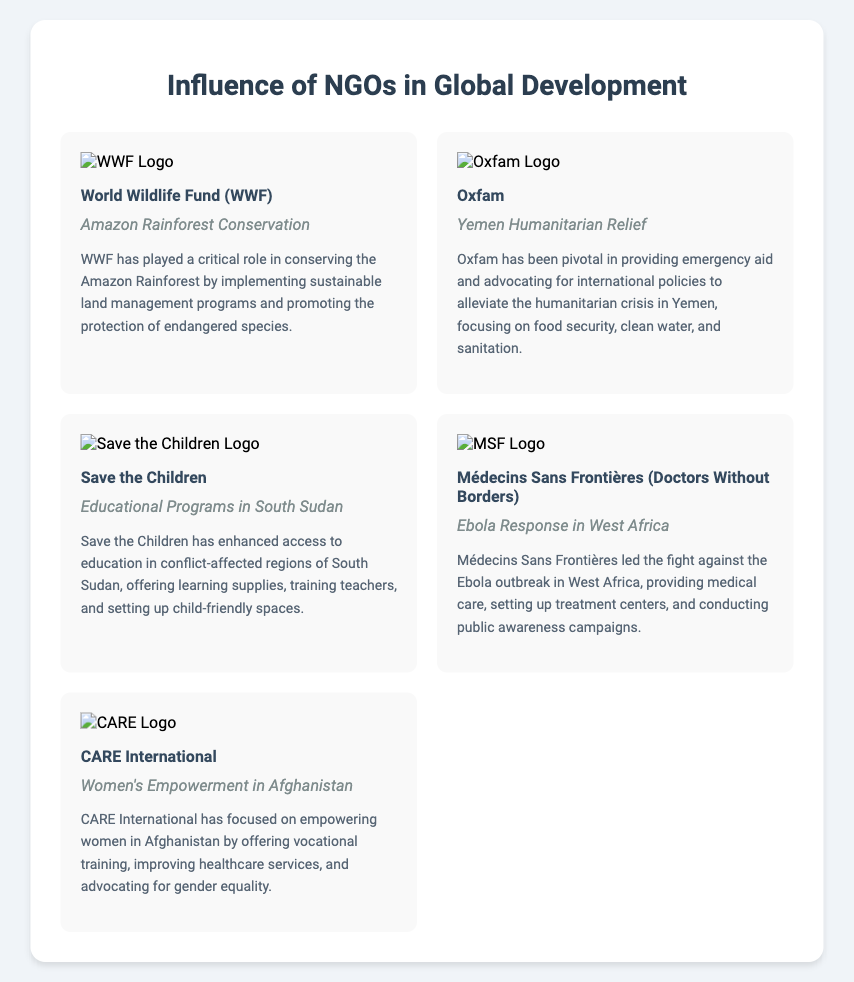What NGO is associated with the Amazon Rainforest Conservation? The document lists the World Wildlife Fund (WWF) as the NGO involved in the Amazon Rainforest Conservation project.
Answer: World Wildlife Fund (WWF) What is a project undertaken by Oxfam? According to the document, Oxfam has undertaken the Yemen Humanitarian Relief project.
Answer: Yemen Humanitarian Relief Which NGO focuses on women's empowerment in Afghanistan? The document indicates that CARE International focuses on women's empowerment in Afghanistan.
Answer: CARE International What type of program did Save the Children implement in South Sudan? The document states that Save the Children implemented Educational Programs in South Sudan.
Answer: Educational Programs in South Sudan How did Médecins Sans Frontières contribute during the Ebola outbreak? The document explains that Médecins Sans Frontières provided medical care and set up treatment centers during the Ebola outbreak.
Answer: Medical care Which NGO logo appears in the document alongside a project description for Yemen? Oxfam's logo appears in the document alongside the project description for Yemen.
Answer: Oxfam What common theme is reflected across most projects described? The document showcases a common theme of humanitarian aid and development initiatives addressing critical issues like health and education.
Answer: Humanitarian aid Which organization enhanced access to education? Save the Children is the organization that enhanced access to education in the document.
Answer: Save the Children 